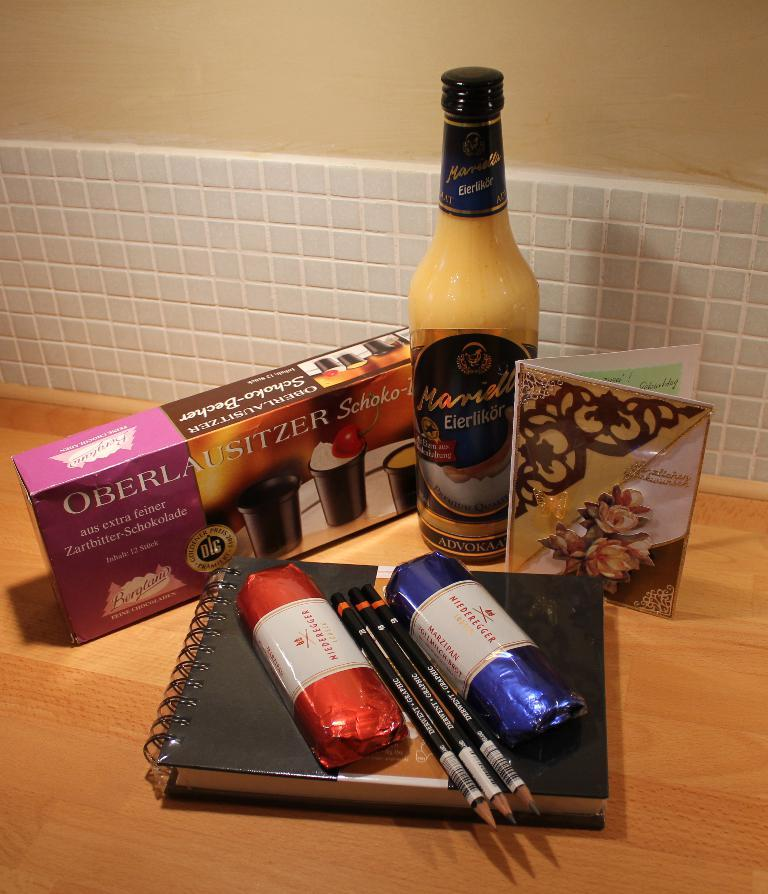<image>
Write a terse but informative summary of the picture. Products in a kitchen such as chocolate shot glasses called Oberlausitzer 